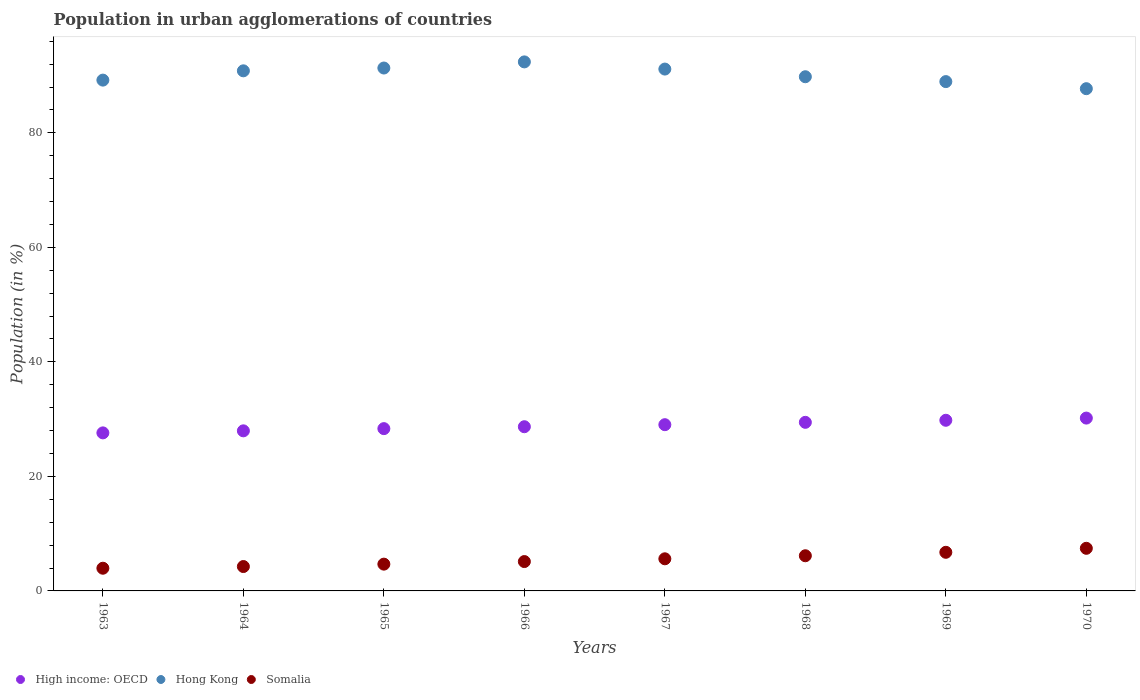What is the percentage of population in urban agglomerations in High income: OECD in 1968?
Provide a succinct answer. 29.44. Across all years, what is the maximum percentage of population in urban agglomerations in Somalia?
Provide a succinct answer. 7.44. Across all years, what is the minimum percentage of population in urban agglomerations in High income: OECD?
Provide a short and direct response. 27.6. In which year was the percentage of population in urban agglomerations in High income: OECD minimum?
Provide a succinct answer. 1963. What is the total percentage of population in urban agglomerations in Hong Kong in the graph?
Offer a terse response. 721.34. What is the difference between the percentage of population in urban agglomerations in Hong Kong in 1969 and that in 1970?
Provide a succinct answer. 1.24. What is the difference between the percentage of population in urban agglomerations in Hong Kong in 1965 and the percentage of population in urban agglomerations in High income: OECD in 1963?
Your answer should be compact. 63.72. What is the average percentage of population in urban agglomerations in Somalia per year?
Offer a terse response. 5.5. In the year 1969, what is the difference between the percentage of population in urban agglomerations in Hong Kong and percentage of population in urban agglomerations in High income: OECD?
Make the answer very short. 59.15. In how many years, is the percentage of population in urban agglomerations in Hong Kong greater than 16 %?
Provide a short and direct response. 8. What is the ratio of the percentage of population in urban agglomerations in High income: OECD in 1965 to that in 1967?
Keep it short and to the point. 0.98. What is the difference between the highest and the second highest percentage of population in urban agglomerations in High income: OECD?
Make the answer very short. 0.38. What is the difference between the highest and the lowest percentage of population in urban agglomerations in Somalia?
Keep it short and to the point. 3.48. In how many years, is the percentage of population in urban agglomerations in Hong Kong greater than the average percentage of population in urban agglomerations in Hong Kong taken over all years?
Your answer should be very brief. 4. Is the sum of the percentage of population in urban agglomerations in Hong Kong in 1964 and 1968 greater than the maximum percentage of population in urban agglomerations in High income: OECD across all years?
Ensure brevity in your answer.  Yes. Is it the case that in every year, the sum of the percentage of population in urban agglomerations in Somalia and percentage of population in urban agglomerations in High income: OECD  is greater than the percentage of population in urban agglomerations in Hong Kong?
Ensure brevity in your answer.  No. Is the percentage of population in urban agglomerations in Somalia strictly greater than the percentage of population in urban agglomerations in Hong Kong over the years?
Give a very brief answer. No. Is the percentage of population in urban agglomerations in Somalia strictly less than the percentage of population in urban agglomerations in High income: OECD over the years?
Your answer should be compact. Yes. How many dotlines are there?
Keep it short and to the point. 3. How many years are there in the graph?
Your answer should be very brief. 8. Are the values on the major ticks of Y-axis written in scientific E-notation?
Your answer should be compact. No. Does the graph contain grids?
Offer a terse response. No. How are the legend labels stacked?
Keep it short and to the point. Horizontal. What is the title of the graph?
Give a very brief answer. Population in urban agglomerations of countries. Does "Niger" appear as one of the legend labels in the graph?
Keep it short and to the point. No. What is the label or title of the X-axis?
Offer a very short reply. Years. What is the label or title of the Y-axis?
Give a very brief answer. Population (in %). What is the Population (in %) in High income: OECD in 1963?
Offer a very short reply. 27.6. What is the Population (in %) of Hong Kong in 1963?
Offer a very short reply. 89.21. What is the Population (in %) of Somalia in 1963?
Ensure brevity in your answer.  3.96. What is the Population (in %) of High income: OECD in 1964?
Provide a short and direct response. 27.96. What is the Population (in %) in Hong Kong in 1964?
Provide a succinct answer. 90.83. What is the Population (in %) of Somalia in 1964?
Your response must be concise. 4.26. What is the Population (in %) in High income: OECD in 1965?
Your answer should be very brief. 28.34. What is the Population (in %) of Hong Kong in 1965?
Give a very brief answer. 91.32. What is the Population (in %) of Somalia in 1965?
Ensure brevity in your answer.  4.68. What is the Population (in %) of High income: OECD in 1966?
Your response must be concise. 28.68. What is the Population (in %) in Hong Kong in 1966?
Keep it short and to the point. 92.39. What is the Population (in %) in Somalia in 1966?
Your answer should be very brief. 5.13. What is the Population (in %) in High income: OECD in 1967?
Ensure brevity in your answer.  29.03. What is the Population (in %) of Hong Kong in 1967?
Keep it short and to the point. 91.14. What is the Population (in %) of Somalia in 1967?
Give a very brief answer. 5.61. What is the Population (in %) in High income: OECD in 1968?
Ensure brevity in your answer.  29.44. What is the Population (in %) in Hong Kong in 1968?
Provide a short and direct response. 89.8. What is the Population (in %) in Somalia in 1968?
Your response must be concise. 6.14. What is the Population (in %) in High income: OECD in 1969?
Your response must be concise. 29.8. What is the Population (in %) in Hong Kong in 1969?
Make the answer very short. 88.95. What is the Population (in %) in Somalia in 1969?
Offer a terse response. 6.74. What is the Population (in %) of High income: OECD in 1970?
Keep it short and to the point. 30.18. What is the Population (in %) of Hong Kong in 1970?
Make the answer very short. 87.71. What is the Population (in %) of Somalia in 1970?
Provide a succinct answer. 7.44. Across all years, what is the maximum Population (in %) in High income: OECD?
Provide a succinct answer. 30.18. Across all years, what is the maximum Population (in %) in Hong Kong?
Your response must be concise. 92.39. Across all years, what is the maximum Population (in %) in Somalia?
Offer a terse response. 7.44. Across all years, what is the minimum Population (in %) in High income: OECD?
Your answer should be compact. 27.6. Across all years, what is the minimum Population (in %) in Hong Kong?
Provide a short and direct response. 87.71. Across all years, what is the minimum Population (in %) in Somalia?
Your answer should be very brief. 3.96. What is the total Population (in %) in High income: OECD in the graph?
Your answer should be very brief. 231.04. What is the total Population (in %) in Hong Kong in the graph?
Offer a terse response. 721.34. What is the total Population (in %) in Somalia in the graph?
Give a very brief answer. 43.97. What is the difference between the Population (in %) of High income: OECD in 1963 and that in 1964?
Ensure brevity in your answer.  -0.36. What is the difference between the Population (in %) of Hong Kong in 1963 and that in 1964?
Offer a terse response. -1.62. What is the difference between the Population (in %) in Somalia in 1963 and that in 1964?
Give a very brief answer. -0.3. What is the difference between the Population (in %) of High income: OECD in 1963 and that in 1965?
Make the answer very short. -0.74. What is the difference between the Population (in %) of Hong Kong in 1963 and that in 1965?
Offer a terse response. -2.11. What is the difference between the Population (in %) of Somalia in 1963 and that in 1965?
Ensure brevity in your answer.  -0.71. What is the difference between the Population (in %) of High income: OECD in 1963 and that in 1966?
Ensure brevity in your answer.  -1.07. What is the difference between the Population (in %) of Hong Kong in 1963 and that in 1966?
Ensure brevity in your answer.  -3.18. What is the difference between the Population (in %) in Somalia in 1963 and that in 1966?
Your answer should be very brief. -1.16. What is the difference between the Population (in %) in High income: OECD in 1963 and that in 1967?
Your answer should be compact. -1.43. What is the difference between the Population (in %) in Hong Kong in 1963 and that in 1967?
Offer a very short reply. -1.93. What is the difference between the Population (in %) in Somalia in 1963 and that in 1967?
Offer a very short reply. -1.65. What is the difference between the Population (in %) of High income: OECD in 1963 and that in 1968?
Your response must be concise. -1.84. What is the difference between the Population (in %) in Hong Kong in 1963 and that in 1968?
Ensure brevity in your answer.  -0.59. What is the difference between the Population (in %) of Somalia in 1963 and that in 1968?
Your answer should be compact. -2.18. What is the difference between the Population (in %) in High income: OECD in 1963 and that in 1969?
Keep it short and to the point. -2.2. What is the difference between the Population (in %) in Hong Kong in 1963 and that in 1969?
Make the answer very short. 0.26. What is the difference between the Population (in %) of Somalia in 1963 and that in 1969?
Offer a terse response. -2.78. What is the difference between the Population (in %) in High income: OECD in 1963 and that in 1970?
Your answer should be compact. -2.58. What is the difference between the Population (in %) of Hong Kong in 1963 and that in 1970?
Ensure brevity in your answer.  1.5. What is the difference between the Population (in %) of Somalia in 1963 and that in 1970?
Offer a terse response. -3.48. What is the difference between the Population (in %) in High income: OECD in 1964 and that in 1965?
Provide a short and direct response. -0.39. What is the difference between the Population (in %) in Hong Kong in 1964 and that in 1965?
Give a very brief answer. -0.49. What is the difference between the Population (in %) in Somalia in 1964 and that in 1965?
Give a very brief answer. -0.42. What is the difference between the Population (in %) of High income: OECD in 1964 and that in 1966?
Make the answer very short. -0.72. What is the difference between the Population (in %) in Hong Kong in 1964 and that in 1966?
Offer a terse response. -1.56. What is the difference between the Population (in %) in Somalia in 1964 and that in 1966?
Provide a short and direct response. -0.87. What is the difference between the Population (in %) in High income: OECD in 1964 and that in 1967?
Offer a terse response. -1.07. What is the difference between the Population (in %) in Hong Kong in 1964 and that in 1967?
Provide a short and direct response. -0.31. What is the difference between the Population (in %) of Somalia in 1964 and that in 1967?
Offer a terse response. -1.35. What is the difference between the Population (in %) in High income: OECD in 1964 and that in 1968?
Your answer should be compact. -1.49. What is the difference between the Population (in %) in Hong Kong in 1964 and that in 1968?
Provide a succinct answer. 1.03. What is the difference between the Population (in %) of Somalia in 1964 and that in 1968?
Give a very brief answer. -1.88. What is the difference between the Population (in %) of High income: OECD in 1964 and that in 1969?
Keep it short and to the point. -1.84. What is the difference between the Population (in %) of Hong Kong in 1964 and that in 1969?
Offer a terse response. 1.88. What is the difference between the Population (in %) of Somalia in 1964 and that in 1969?
Your answer should be compact. -2.49. What is the difference between the Population (in %) of High income: OECD in 1964 and that in 1970?
Your answer should be very brief. -2.23. What is the difference between the Population (in %) of Hong Kong in 1964 and that in 1970?
Offer a very short reply. 3.12. What is the difference between the Population (in %) in Somalia in 1964 and that in 1970?
Your answer should be very brief. -3.18. What is the difference between the Population (in %) of High income: OECD in 1965 and that in 1966?
Give a very brief answer. -0.33. What is the difference between the Population (in %) in Hong Kong in 1965 and that in 1966?
Provide a succinct answer. -1.07. What is the difference between the Population (in %) in Somalia in 1965 and that in 1966?
Your answer should be very brief. -0.45. What is the difference between the Population (in %) in High income: OECD in 1965 and that in 1967?
Keep it short and to the point. -0.69. What is the difference between the Population (in %) in Hong Kong in 1965 and that in 1967?
Offer a terse response. 0.18. What is the difference between the Population (in %) of Somalia in 1965 and that in 1967?
Provide a succinct answer. -0.93. What is the difference between the Population (in %) of High income: OECD in 1965 and that in 1968?
Give a very brief answer. -1.1. What is the difference between the Population (in %) of Hong Kong in 1965 and that in 1968?
Give a very brief answer. 1.52. What is the difference between the Population (in %) in Somalia in 1965 and that in 1968?
Your answer should be very brief. -1.46. What is the difference between the Population (in %) in High income: OECD in 1965 and that in 1969?
Provide a succinct answer. -1.46. What is the difference between the Population (in %) in Hong Kong in 1965 and that in 1969?
Offer a terse response. 2.37. What is the difference between the Population (in %) of Somalia in 1965 and that in 1969?
Give a very brief answer. -2.07. What is the difference between the Population (in %) in High income: OECD in 1965 and that in 1970?
Your answer should be compact. -1.84. What is the difference between the Population (in %) in Hong Kong in 1965 and that in 1970?
Give a very brief answer. 3.61. What is the difference between the Population (in %) of Somalia in 1965 and that in 1970?
Your answer should be very brief. -2.77. What is the difference between the Population (in %) of High income: OECD in 1966 and that in 1967?
Give a very brief answer. -0.36. What is the difference between the Population (in %) in Hong Kong in 1966 and that in 1967?
Make the answer very short. 1.25. What is the difference between the Population (in %) of Somalia in 1966 and that in 1967?
Give a very brief answer. -0.48. What is the difference between the Population (in %) in High income: OECD in 1966 and that in 1968?
Your answer should be very brief. -0.77. What is the difference between the Population (in %) in Hong Kong in 1966 and that in 1968?
Provide a succinct answer. 2.59. What is the difference between the Population (in %) in Somalia in 1966 and that in 1968?
Give a very brief answer. -1.01. What is the difference between the Population (in %) of High income: OECD in 1966 and that in 1969?
Your answer should be compact. -1.13. What is the difference between the Population (in %) in Hong Kong in 1966 and that in 1969?
Keep it short and to the point. 3.44. What is the difference between the Population (in %) in Somalia in 1966 and that in 1969?
Provide a succinct answer. -1.62. What is the difference between the Population (in %) in High income: OECD in 1966 and that in 1970?
Your response must be concise. -1.51. What is the difference between the Population (in %) of Hong Kong in 1966 and that in 1970?
Your answer should be very brief. 4.68. What is the difference between the Population (in %) of Somalia in 1966 and that in 1970?
Provide a succinct answer. -2.32. What is the difference between the Population (in %) in High income: OECD in 1967 and that in 1968?
Offer a very short reply. -0.41. What is the difference between the Population (in %) of Hong Kong in 1967 and that in 1968?
Make the answer very short. 1.34. What is the difference between the Population (in %) of Somalia in 1967 and that in 1968?
Give a very brief answer. -0.53. What is the difference between the Population (in %) of High income: OECD in 1967 and that in 1969?
Offer a very short reply. -0.77. What is the difference between the Population (in %) of Hong Kong in 1967 and that in 1969?
Give a very brief answer. 2.19. What is the difference between the Population (in %) of Somalia in 1967 and that in 1969?
Keep it short and to the point. -1.13. What is the difference between the Population (in %) of High income: OECD in 1967 and that in 1970?
Your response must be concise. -1.15. What is the difference between the Population (in %) of Hong Kong in 1967 and that in 1970?
Ensure brevity in your answer.  3.42. What is the difference between the Population (in %) in Somalia in 1967 and that in 1970?
Give a very brief answer. -1.83. What is the difference between the Population (in %) in High income: OECD in 1968 and that in 1969?
Make the answer very short. -0.36. What is the difference between the Population (in %) of Hong Kong in 1968 and that in 1969?
Your response must be concise. 0.85. What is the difference between the Population (in %) in Somalia in 1968 and that in 1969?
Keep it short and to the point. -0.6. What is the difference between the Population (in %) of High income: OECD in 1968 and that in 1970?
Make the answer very short. -0.74. What is the difference between the Population (in %) in Hong Kong in 1968 and that in 1970?
Provide a short and direct response. 2.09. What is the difference between the Population (in %) of Somalia in 1968 and that in 1970?
Offer a terse response. -1.3. What is the difference between the Population (in %) of High income: OECD in 1969 and that in 1970?
Ensure brevity in your answer.  -0.38. What is the difference between the Population (in %) of Hong Kong in 1969 and that in 1970?
Give a very brief answer. 1.24. What is the difference between the Population (in %) in Somalia in 1969 and that in 1970?
Make the answer very short. -0.7. What is the difference between the Population (in %) of High income: OECD in 1963 and the Population (in %) of Hong Kong in 1964?
Your answer should be very brief. -63.23. What is the difference between the Population (in %) in High income: OECD in 1963 and the Population (in %) in Somalia in 1964?
Provide a succinct answer. 23.34. What is the difference between the Population (in %) of Hong Kong in 1963 and the Population (in %) of Somalia in 1964?
Your answer should be compact. 84.95. What is the difference between the Population (in %) in High income: OECD in 1963 and the Population (in %) in Hong Kong in 1965?
Your answer should be compact. -63.72. What is the difference between the Population (in %) of High income: OECD in 1963 and the Population (in %) of Somalia in 1965?
Your response must be concise. 22.92. What is the difference between the Population (in %) of Hong Kong in 1963 and the Population (in %) of Somalia in 1965?
Make the answer very short. 84.53. What is the difference between the Population (in %) of High income: OECD in 1963 and the Population (in %) of Hong Kong in 1966?
Provide a succinct answer. -64.79. What is the difference between the Population (in %) of High income: OECD in 1963 and the Population (in %) of Somalia in 1966?
Make the answer very short. 22.47. What is the difference between the Population (in %) in Hong Kong in 1963 and the Population (in %) in Somalia in 1966?
Your answer should be very brief. 84.08. What is the difference between the Population (in %) in High income: OECD in 1963 and the Population (in %) in Hong Kong in 1967?
Your response must be concise. -63.53. What is the difference between the Population (in %) of High income: OECD in 1963 and the Population (in %) of Somalia in 1967?
Your answer should be compact. 21.99. What is the difference between the Population (in %) of Hong Kong in 1963 and the Population (in %) of Somalia in 1967?
Provide a short and direct response. 83.6. What is the difference between the Population (in %) in High income: OECD in 1963 and the Population (in %) in Hong Kong in 1968?
Your answer should be very brief. -62.2. What is the difference between the Population (in %) in High income: OECD in 1963 and the Population (in %) in Somalia in 1968?
Provide a succinct answer. 21.46. What is the difference between the Population (in %) of Hong Kong in 1963 and the Population (in %) of Somalia in 1968?
Provide a succinct answer. 83.07. What is the difference between the Population (in %) of High income: OECD in 1963 and the Population (in %) of Hong Kong in 1969?
Make the answer very short. -61.35. What is the difference between the Population (in %) in High income: OECD in 1963 and the Population (in %) in Somalia in 1969?
Your answer should be very brief. 20.86. What is the difference between the Population (in %) of Hong Kong in 1963 and the Population (in %) of Somalia in 1969?
Make the answer very short. 82.46. What is the difference between the Population (in %) in High income: OECD in 1963 and the Population (in %) in Hong Kong in 1970?
Offer a very short reply. -60.11. What is the difference between the Population (in %) in High income: OECD in 1963 and the Population (in %) in Somalia in 1970?
Provide a short and direct response. 20.16. What is the difference between the Population (in %) in Hong Kong in 1963 and the Population (in %) in Somalia in 1970?
Provide a short and direct response. 81.77. What is the difference between the Population (in %) in High income: OECD in 1964 and the Population (in %) in Hong Kong in 1965?
Make the answer very short. -63.36. What is the difference between the Population (in %) in High income: OECD in 1964 and the Population (in %) in Somalia in 1965?
Offer a very short reply. 23.28. What is the difference between the Population (in %) in Hong Kong in 1964 and the Population (in %) in Somalia in 1965?
Your answer should be very brief. 86.15. What is the difference between the Population (in %) in High income: OECD in 1964 and the Population (in %) in Hong Kong in 1966?
Provide a succinct answer. -64.43. What is the difference between the Population (in %) in High income: OECD in 1964 and the Population (in %) in Somalia in 1966?
Provide a succinct answer. 22.83. What is the difference between the Population (in %) in Hong Kong in 1964 and the Population (in %) in Somalia in 1966?
Give a very brief answer. 85.7. What is the difference between the Population (in %) in High income: OECD in 1964 and the Population (in %) in Hong Kong in 1967?
Your answer should be compact. -63.18. What is the difference between the Population (in %) in High income: OECD in 1964 and the Population (in %) in Somalia in 1967?
Make the answer very short. 22.35. What is the difference between the Population (in %) in Hong Kong in 1964 and the Population (in %) in Somalia in 1967?
Your answer should be compact. 85.22. What is the difference between the Population (in %) of High income: OECD in 1964 and the Population (in %) of Hong Kong in 1968?
Offer a terse response. -61.84. What is the difference between the Population (in %) in High income: OECD in 1964 and the Population (in %) in Somalia in 1968?
Offer a very short reply. 21.82. What is the difference between the Population (in %) in Hong Kong in 1964 and the Population (in %) in Somalia in 1968?
Keep it short and to the point. 84.69. What is the difference between the Population (in %) in High income: OECD in 1964 and the Population (in %) in Hong Kong in 1969?
Give a very brief answer. -60.99. What is the difference between the Population (in %) in High income: OECD in 1964 and the Population (in %) in Somalia in 1969?
Your response must be concise. 21.21. What is the difference between the Population (in %) of Hong Kong in 1964 and the Population (in %) of Somalia in 1969?
Offer a very short reply. 84.09. What is the difference between the Population (in %) in High income: OECD in 1964 and the Population (in %) in Hong Kong in 1970?
Give a very brief answer. -59.75. What is the difference between the Population (in %) in High income: OECD in 1964 and the Population (in %) in Somalia in 1970?
Offer a terse response. 20.51. What is the difference between the Population (in %) of Hong Kong in 1964 and the Population (in %) of Somalia in 1970?
Provide a succinct answer. 83.39. What is the difference between the Population (in %) of High income: OECD in 1965 and the Population (in %) of Hong Kong in 1966?
Give a very brief answer. -64.05. What is the difference between the Population (in %) of High income: OECD in 1965 and the Population (in %) of Somalia in 1966?
Your answer should be very brief. 23.22. What is the difference between the Population (in %) in Hong Kong in 1965 and the Population (in %) in Somalia in 1966?
Your answer should be very brief. 86.19. What is the difference between the Population (in %) of High income: OECD in 1965 and the Population (in %) of Hong Kong in 1967?
Your response must be concise. -62.79. What is the difference between the Population (in %) in High income: OECD in 1965 and the Population (in %) in Somalia in 1967?
Keep it short and to the point. 22.73. What is the difference between the Population (in %) of Hong Kong in 1965 and the Population (in %) of Somalia in 1967?
Provide a short and direct response. 85.71. What is the difference between the Population (in %) of High income: OECD in 1965 and the Population (in %) of Hong Kong in 1968?
Ensure brevity in your answer.  -61.46. What is the difference between the Population (in %) of High income: OECD in 1965 and the Population (in %) of Somalia in 1968?
Your answer should be very brief. 22.2. What is the difference between the Population (in %) in Hong Kong in 1965 and the Population (in %) in Somalia in 1968?
Your response must be concise. 85.18. What is the difference between the Population (in %) of High income: OECD in 1965 and the Population (in %) of Hong Kong in 1969?
Offer a terse response. -60.61. What is the difference between the Population (in %) of High income: OECD in 1965 and the Population (in %) of Somalia in 1969?
Give a very brief answer. 21.6. What is the difference between the Population (in %) of Hong Kong in 1965 and the Population (in %) of Somalia in 1969?
Offer a very short reply. 84.57. What is the difference between the Population (in %) of High income: OECD in 1965 and the Population (in %) of Hong Kong in 1970?
Provide a short and direct response. -59.37. What is the difference between the Population (in %) of High income: OECD in 1965 and the Population (in %) of Somalia in 1970?
Give a very brief answer. 20.9. What is the difference between the Population (in %) of Hong Kong in 1965 and the Population (in %) of Somalia in 1970?
Provide a succinct answer. 83.88. What is the difference between the Population (in %) of High income: OECD in 1966 and the Population (in %) of Hong Kong in 1967?
Give a very brief answer. -62.46. What is the difference between the Population (in %) of High income: OECD in 1966 and the Population (in %) of Somalia in 1967?
Offer a very short reply. 23.07. What is the difference between the Population (in %) in Hong Kong in 1966 and the Population (in %) in Somalia in 1967?
Make the answer very short. 86.78. What is the difference between the Population (in %) of High income: OECD in 1966 and the Population (in %) of Hong Kong in 1968?
Ensure brevity in your answer.  -61.12. What is the difference between the Population (in %) of High income: OECD in 1966 and the Population (in %) of Somalia in 1968?
Offer a very short reply. 22.53. What is the difference between the Population (in %) of Hong Kong in 1966 and the Population (in %) of Somalia in 1968?
Your answer should be compact. 86.25. What is the difference between the Population (in %) of High income: OECD in 1966 and the Population (in %) of Hong Kong in 1969?
Provide a short and direct response. -60.27. What is the difference between the Population (in %) of High income: OECD in 1966 and the Population (in %) of Somalia in 1969?
Your answer should be very brief. 21.93. What is the difference between the Population (in %) of Hong Kong in 1966 and the Population (in %) of Somalia in 1969?
Offer a terse response. 85.65. What is the difference between the Population (in %) in High income: OECD in 1966 and the Population (in %) in Hong Kong in 1970?
Keep it short and to the point. -59.04. What is the difference between the Population (in %) of High income: OECD in 1966 and the Population (in %) of Somalia in 1970?
Provide a short and direct response. 21.23. What is the difference between the Population (in %) of Hong Kong in 1966 and the Population (in %) of Somalia in 1970?
Make the answer very short. 84.95. What is the difference between the Population (in %) of High income: OECD in 1967 and the Population (in %) of Hong Kong in 1968?
Offer a very short reply. -60.77. What is the difference between the Population (in %) of High income: OECD in 1967 and the Population (in %) of Somalia in 1968?
Give a very brief answer. 22.89. What is the difference between the Population (in %) in Hong Kong in 1967 and the Population (in %) in Somalia in 1968?
Your response must be concise. 84.99. What is the difference between the Population (in %) of High income: OECD in 1967 and the Population (in %) of Hong Kong in 1969?
Offer a terse response. -59.92. What is the difference between the Population (in %) in High income: OECD in 1967 and the Population (in %) in Somalia in 1969?
Your response must be concise. 22.29. What is the difference between the Population (in %) of Hong Kong in 1967 and the Population (in %) of Somalia in 1969?
Keep it short and to the point. 84.39. What is the difference between the Population (in %) of High income: OECD in 1967 and the Population (in %) of Hong Kong in 1970?
Your answer should be very brief. -58.68. What is the difference between the Population (in %) in High income: OECD in 1967 and the Population (in %) in Somalia in 1970?
Provide a short and direct response. 21.59. What is the difference between the Population (in %) in Hong Kong in 1967 and the Population (in %) in Somalia in 1970?
Make the answer very short. 83.69. What is the difference between the Population (in %) in High income: OECD in 1968 and the Population (in %) in Hong Kong in 1969?
Give a very brief answer. -59.51. What is the difference between the Population (in %) of High income: OECD in 1968 and the Population (in %) of Somalia in 1969?
Offer a very short reply. 22.7. What is the difference between the Population (in %) of Hong Kong in 1968 and the Population (in %) of Somalia in 1969?
Provide a short and direct response. 83.05. What is the difference between the Population (in %) of High income: OECD in 1968 and the Population (in %) of Hong Kong in 1970?
Make the answer very short. -58.27. What is the difference between the Population (in %) of High income: OECD in 1968 and the Population (in %) of Somalia in 1970?
Keep it short and to the point. 22. What is the difference between the Population (in %) of Hong Kong in 1968 and the Population (in %) of Somalia in 1970?
Your answer should be compact. 82.36. What is the difference between the Population (in %) in High income: OECD in 1969 and the Population (in %) in Hong Kong in 1970?
Offer a very short reply. -57.91. What is the difference between the Population (in %) in High income: OECD in 1969 and the Population (in %) in Somalia in 1970?
Keep it short and to the point. 22.36. What is the difference between the Population (in %) in Hong Kong in 1969 and the Population (in %) in Somalia in 1970?
Your answer should be compact. 81.51. What is the average Population (in %) of High income: OECD per year?
Give a very brief answer. 28.88. What is the average Population (in %) in Hong Kong per year?
Offer a terse response. 90.17. What is the average Population (in %) of Somalia per year?
Your answer should be compact. 5.5. In the year 1963, what is the difference between the Population (in %) of High income: OECD and Population (in %) of Hong Kong?
Keep it short and to the point. -61.61. In the year 1963, what is the difference between the Population (in %) in High income: OECD and Population (in %) in Somalia?
Your answer should be very brief. 23.64. In the year 1963, what is the difference between the Population (in %) in Hong Kong and Population (in %) in Somalia?
Ensure brevity in your answer.  85.25. In the year 1964, what is the difference between the Population (in %) in High income: OECD and Population (in %) in Hong Kong?
Your response must be concise. -62.87. In the year 1964, what is the difference between the Population (in %) of High income: OECD and Population (in %) of Somalia?
Your answer should be very brief. 23.7. In the year 1964, what is the difference between the Population (in %) of Hong Kong and Population (in %) of Somalia?
Keep it short and to the point. 86.57. In the year 1965, what is the difference between the Population (in %) of High income: OECD and Population (in %) of Hong Kong?
Your answer should be very brief. -62.98. In the year 1965, what is the difference between the Population (in %) of High income: OECD and Population (in %) of Somalia?
Offer a terse response. 23.67. In the year 1965, what is the difference between the Population (in %) in Hong Kong and Population (in %) in Somalia?
Provide a short and direct response. 86.64. In the year 1966, what is the difference between the Population (in %) in High income: OECD and Population (in %) in Hong Kong?
Give a very brief answer. -63.71. In the year 1966, what is the difference between the Population (in %) of High income: OECD and Population (in %) of Somalia?
Offer a very short reply. 23.55. In the year 1966, what is the difference between the Population (in %) of Hong Kong and Population (in %) of Somalia?
Your answer should be compact. 87.26. In the year 1967, what is the difference between the Population (in %) in High income: OECD and Population (in %) in Hong Kong?
Make the answer very short. -62.1. In the year 1967, what is the difference between the Population (in %) of High income: OECD and Population (in %) of Somalia?
Keep it short and to the point. 23.42. In the year 1967, what is the difference between the Population (in %) of Hong Kong and Population (in %) of Somalia?
Your answer should be compact. 85.53. In the year 1968, what is the difference between the Population (in %) in High income: OECD and Population (in %) in Hong Kong?
Your response must be concise. -60.35. In the year 1968, what is the difference between the Population (in %) of High income: OECD and Population (in %) of Somalia?
Ensure brevity in your answer.  23.3. In the year 1968, what is the difference between the Population (in %) of Hong Kong and Population (in %) of Somalia?
Offer a terse response. 83.66. In the year 1969, what is the difference between the Population (in %) of High income: OECD and Population (in %) of Hong Kong?
Your response must be concise. -59.15. In the year 1969, what is the difference between the Population (in %) in High income: OECD and Population (in %) in Somalia?
Keep it short and to the point. 23.06. In the year 1969, what is the difference between the Population (in %) in Hong Kong and Population (in %) in Somalia?
Provide a short and direct response. 82.2. In the year 1970, what is the difference between the Population (in %) in High income: OECD and Population (in %) in Hong Kong?
Provide a short and direct response. -57.53. In the year 1970, what is the difference between the Population (in %) of High income: OECD and Population (in %) of Somalia?
Make the answer very short. 22.74. In the year 1970, what is the difference between the Population (in %) in Hong Kong and Population (in %) in Somalia?
Provide a short and direct response. 80.27. What is the ratio of the Population (in %) of High income: OECD in 1963 to that in 1964?
Your response must be concise. 0.99. What is the ratio of the Population (in %) in Hong Kong in 1963 to that in 1964?
Offer a terse response. 0.98. What is the ratio of the Population (in %) in Somalia in 1963 to that in 1964?
Offer a very short reply. 0.93. What is the ratio of the Population (in %) of High income: OECD in 1963 to that in 1965?
Ensure brevity in your answer.  0.97. What is the ratio of the Population (in %) in Hong Kong in 1963 to that in 1965?
Your answer should be very brief. 0.98. What is the ratio of the Population (in %) of Somalia in 1963 to that in 1965?
Give a very brief answer. 0.85. What is the ratio of the Population (in %) in High income: OECD in 1963 to that in 1966?
Offer a very short reply. 0.96. What is the ratio of the Population (in %) of Hong Kong in 1963 to that in 1966?
Give a very brief answer. 0.97. What is the ratio of the Population (in %) of Somalia in 1963 to that in 1966?
Your answer should be very brief. 0.77. What is the ratio of the Population (in %) of High income: OECD in 1963 to that in 1967?
Offer a terse response. 0.95. What is the ratio of the Population (in %) in Hong Kong in 1963 to that in 1967?
Give a very brief answer. 0.98. What is the ratio of the Population (in %) of Somalia in 1963 to that in 1967?
Offer a terse response. 0.71. What is the ratio of the Population (in %) of High income: OECD in 1963 to that in 1968?
Provide a short and direct response. 0.94. What is the ratio of the Population (in %) of Somalia in 1963 to that in 1968?
Your answer should be very brief. 0.65. What is the ratio of the Population (in %) of High income: OECD in 1963 to that in 1969?
Your response must be concise. 0.93. What is the ratio of the Population (in %) of Hong Kong in 1963 to that in 1969?
Your answer should be very brief. 1. What is the ratio of the Population (in %) in Somalia in 1963 to that in 1969?
Provide a short and direct response. 0.59. What is the ratio of the Population (in %) in High income: OECD in 1963 to that in 1970?
Provide a succinct answer. 0.91. What is the ratio of the Population (in %) in Hong Kong in 1963 to that in 1970?
Make the answer very short. 1.02. What is the ratio of the Population (in %) in Somalia in 1963 to that in 1970?
Provide a succinct answer. 0.53. What is the ratio of the Population (in %) in High income: OECD in 1964 to that in 1965?
Make the answer very short. 0.99. What is the ratio of the Population (in %) of Somalia in 1964 to that in 1965?
Make the answer very short. 0.91. What is the ratio of the Population (in %) in High income: OECD in 1964 to that in 1966?
Provide a succinct answer. 0.97. What is the ratio of the Population (in %) in Hong Kong in 1964 to that in 1966?
Offer a very short reply. 0.98. What is the ratio of the Population (in %) of Somalia in 1964 to that in 1966?
Provide a succinct answer. 0.83. What is the ratio of the Population (in %) in High income: OECD in 1964 to that in 1967?
Give a very brief answer. 0.96. What is the ratio of the Population (in %) in Somalia in 1964 to that in 1967?
Offer a very short reply. 0.76. What is the ratio of the Population (in %) of High income: OECD in 1964 to that in 1968?
Give a very brief answer. 0.95. What is the ratio of the Population (in %) in Hong Kong in 1964 to that in 1968?
Offer a very short reply. 1.01. What is the ratio of the Population (in %) in Somalia in 1964 to that in 1968?
Your response must be concise. 0.69. What is the ratio of the Population (in %) of High income: OECD in 1964 to that in 1969?
Provide a succinct answer. 0.94. What is the ratio of the Population (in %) of Hong Kong in 1964 to that in 1969?
Give a very brief answer. 1.02. What is the ratio of the Population (in %) of Somalia in 1964 to that in 1969?
Offer a very short reply. 0.63. What is the ratio of the Population (in %) in High income: OECD in 1964 to that in 1970?
Keep it short and to the point. 0.93. What is the ratio of the Population (in %) of Hong Kong in 1964 to that in 1970?
Your response must be concise. 1.04. What is the ratio of the Population (in %) of Somalia in 1964 to that in 1970?
Your answer should be compact. 0.57. What is the ratio of the Population (in %) of High income: OECD in 1965 to that in 1966?
Provide a short and direct response. 0.99. What is the ratio of the Population (in %) of Hong Kong in 1965 to that in 1966?
Give a very brief answer. 0.99. What is the ratio of the Population (in %) of Somalia in 1965 to that in 1966?
Keep it short and to the point. 0.91. What is the ratio of the Population (in %) of High income: OECD in 1965 to that in 1967?
Offer a terse response. 0.98. What is the ratio of the Population (in %) of Somalia in 1965 to that in 1967?
Your answer should be compact. 0.83. What is the ratio of the Population (in %) of High income: OECD in 1965 to that in 1968?
Offer a very short reply. 0.96. What is the ratio of the Population (in %) of Hong Kong in 1965 to that in 1968?
Keep it short and to the point. 1.02. What is the ratio of the Population (in %) in Somalia in 1965 to that in 1968?
Your answer should be compact. 0.76. What is the ratio of the Population (in %) of High income: OECD in 1965 to that in 1969?
Your response must be concise. 0.95. What is the ratio of the Population (in %) in Hong Kong in 1965 to that in 1969?
Ensure brevity in your answer.  1.03. What is the ratio of the Population (in %) of Somalia in 1965 to that in 1969?
Keep it short and to the point. 0.69. What is the ratio of the Population (in %) of High income: OECD in 1965 to that in 1970?
Ensure brevity in your answer.  0.94. What is the ratio of the Population (in %) in Hong Kong in 1965 to that in 1970?
Provide a short and direct response. 1.04. What is the ratio of the Population (in %) of Somalia in 1965 to that in 1970?
Make the answer very short. 0.63. What is the ratio of the Population (in %) in Hong Kong in 1966 to that in 1967?
Keep it short and to the point. 1.01. What is the ratio of the Population (in %) in Somalia in 1966 to that in 1967?
Make the answer very short. 0.91. What is the ratio of the Population (in %) in High income: OECD in 1966 to that in 1968?
Offer a very short reply. 0.97. What is the ratio of the Population (in %) of Hong Kong in 1966 to that in 1968?
Make the answer very short. 1.03. What is the ratio of the Population (in %) in Somalia in 1966 to that in 1968?
Make the answer very short. 0.83. What is the ratio of the Population (in %) in High income: OECD in 1966 to that in 1969?
Your answer should be compact. 0.96. What is the ratio of the Population (in %) in Hong Kong in 1966 to that in 1969?
Provide a succinct answer. 1.04. What is the ratio of the Population (in %) of Somalia in 1966 to that in 1969?
Provide a succinct answer. 0.76. What is the ratio of the Population (in %) in Hong Kong in 1966 to that in 1970?
Ensure brevity in your answer.  1.05. What is the ratio of the Population (in %) of Somalia in 1966 to that in 1970?
Make the answer very short. 0.69. What is the ratio of the Population (in %) of Hong Kong in 1967 to that in 1968?
Provide a short and direct response. 1.01. What is the ratio of the Population (in %) of Somalia in 1967 to that in 1968?
Keep it short and to the point. 0.91. What is the ratio of the Population (in %) in High income: OECD in 1967 to that in 1969?
Ensure brevity in your answer.  0.97. What is the ratio of the Population (in %) of Hong Kong in 1967 to that in 1969?
Your answer should be very brief. 1.02. What is the ratio of the Population (in %) in Somalia in 1967 to that in 1969?
Offer a very short reply. 0.83. What is the ratio of the Population (in %) in High income: OECD in 1967 to that in 1970?
Your answer should be compact. 0.96. What is the ratio of the Population (in %) of Hong Kong in 1967 to that in 1970?
Your response must be concise. 1.04. What is the ratio of the Population (in %) in Somalia in 1967 to that in 1970?
Your answer should be compact. 0.75. What is the ratio of the Population (in %) in Hong Kong in 1968 to that in 1969?
Offer a very short reply. 1.01. What is the ratio of the Population (in %) of Somalia in 1968 to that in 1969?
Provide a short and direct response. 0.91. What is the ratio of the Population (in %) of High income: OECD in 1968 to that in 1970?
Offer a very short reply. 0.98. What is the ratio of the Population (in %) in Hong Kong in 1968 to that in 1970?
Provide a short and direct response. 1.02. What is the ratio of the Population (in %) in Somalia in 1968 to that in 1970?
Offer a terse response. 0.83. What is the ratio of the Population (in %) in High income: OECD in 1969 to that in 1970?
Your response must be concise. 0.99. What is the ratio of the Population (in %) in Hong Kong in 1969 to that in 1970?
Your response must be concise. 1.01. What is the ratio of the Population (in %) in Somalia in 1969 to that in 1970?
Provide a succinct answer. 0.91. What is the difference between the highest and the second highest Population (in %) in High income: OECD?
Your answer should be compact. 0.38. What is the difference between the highest and the second highest Population (in %) of Hong Kong?
Ensure brevity in your answer.  1.07. What is the difference between the highest and the second highest Population (in %) in Somalia?
Ensure brevity in your answer.  0.7. What is the difference between the highest and the lowest Population (in %) in High income: OECD?
Offer a very short reply. 2.58. What is the difference between the highest and the lowest Population (in %) in Hong Kong?
Provide a succinct answer. 4.68. What is the difference between the highest and the lowest Population (in %) in Somalia?
Your answer should be compact. 3.48. 